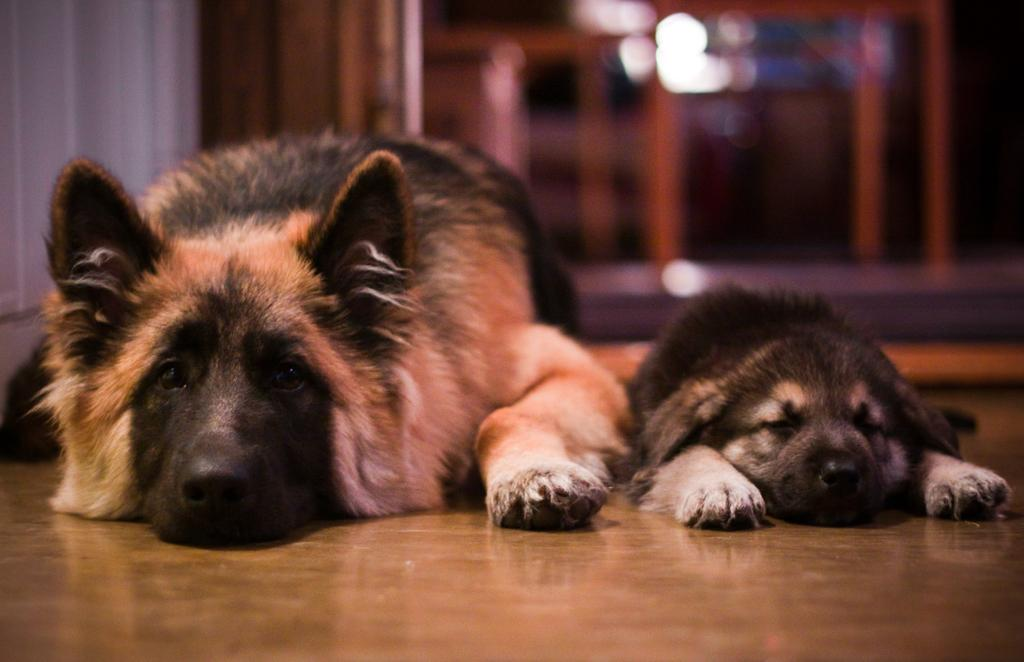What animals are present in the image? There are dogs in the image. Where are the dogs located? The dogs are on the floor. Can you describe the background of the image? The background of the image is blurred. What type of medical advice can be given by the doctor in the image? There is no doctor present in the image; it features dogs on the floor with a blurred background. 